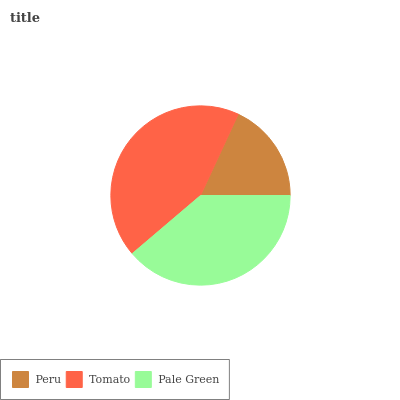Is Peru the minimum?
Answer yes or no. Yes. Is Tomato the maximum?
Answer yes or no. Yes. Is Pale Green the minimum?
Answer yes or no. No. Is Pale Green the maximum?
Answer yes or no. No. Is Tomato greater than Pale Green?
Answer yes or no. Yes. Is Pale Green less than Tomato?
Answer yes or no. Yes. Is Pale Green greater than Tomato?
Answer yes or no. No. Is Tomato less than Pale Green?
Answer yes or no. No. Is Pale Green the high median?
Answer yes or no. Yes. Is Pale Green the low median?
Answer yes or no. Yes. Is Peru the high median?
Answer yes or no. No. Is Tomato the low median?
Answer yes or no. No. 